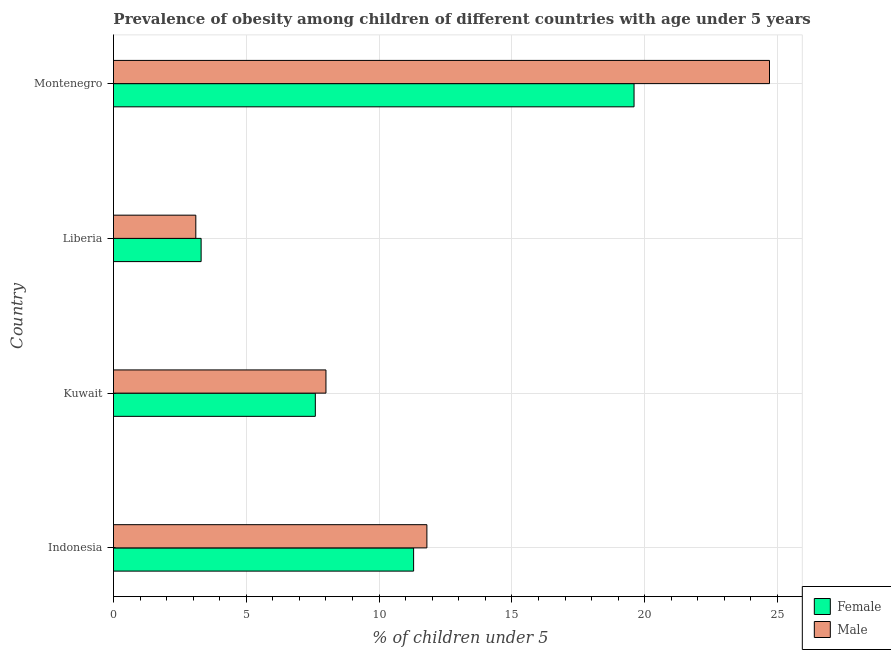How many different coloured bars are there?
Ensure brevity in your answer.  2. Are the number of bars per tick equal to the number of legend labels?
Provide a succinct answer. Yes. Are the number of bars on each tick of the Y-axis equal?
Provide a short and direct response. Yes. How many bars are there on the 3rd tick from the top?
Your response must be concise. 2. What is the label of the 2nd group of bars from the top?
Offer a very short reply. Liberia. In how many cases, is the number of bars for a given country not equal to the number of legend labels?
Your answer should be compact. 0. What is the percentage of obese male children in Liberia?
Your answer should be compact. 3.1. Across all countries, what is the maximum percentage of obese male children?
Ensure brevity in your answer.  24.7. Across all countries, what is the minimum percentage of obese female children?
Provide a succinct answer. 3.3. In which country was the percentage of obese male children maximum?
Your answer should be very brief. Montenegro. In which country was the percentage of obese male children minimum?
Provide a succinct answer. Liberia. What is the total percentage of obese female children in the graph?
Provide a succinct answer. 41.8. What is the difference between the percentage of obese female children in Indonesia and that in Liberia?
Provide a succinct answer. 8. What is the difference between the percentage of obese female children in Indonesia and the percentage of obese male children in Liberia?
Make the answer very short. 8.2. What is the average percentage of obese female children per country?
Make the answer very short. 10.45. In how many countries, is the percentage of obese female children greater than 6 %?
Your answer should be very brief. 3. What is the ratio of the percentage of obese male children in Kuwait to that in Montenegro?
Your answer should be very brief. 0.32. Is the percentage of obese female children in Indonesia less than that in Montenegro?
Provide a succinct answer. Yes. Is the difference between the percentage of obese female children in Indonesia and Liberia greater than the difference between the percentage of obese male children in Indonesia and Liberia?
Give a very brief answer. No. What is the difference between the highest and the second highest percentage of obese male children?
Offer a very short reply. 12.9. What is the difference between the highest and the lowest percentage of obese male children?
Your answer should be compact. 21.6. In how many countries, is the percentage of obese female children greater than the average percentage of obese female children taken over all countries?
Keep it short and to the point. 2. Is the sum of the percentage of obese female children in Indonesia and Liberia greater than the maximum percentage of obese male children across all countries?
Your answer should be compact. No. What does the 2nd bar from the bottom in Kuwait represents?
Offer a terse response. Male. Are all the bars in the graph horizontal?
Offer a terse response. Yes. Are the values on the major ticks of X-axis written in scientific E-notation?
Give a very brief answer. No. Where does the legend appear in the graph?
Offer a terse response. Bottom right. What is the title of the graph?
Make the answer very short. Prevalence of obesity among children of different countries with age under 5 years. Does "Sanitation services" appear as one of the legend labels in the graph?
Give a very brief answer. No. What is the label or title of the X-axis?
Your answer should be very brief.  % of children under 5. What is the  % of children under 5 of Female in Indonesia?
Offer a very short reply. 11.3. What is the  % of children under 5 of Male in Indonesia?
Provide a succinct answer. 11.8. What is the  % of children under 5 in Female in Kuwait?
Your answer should be compact. 7.6. What is the  % of children under 5 in Male in Kuwait?
Your answer should be very brief. 8. What is the  % of children under 5 of Female in Liberia?
Provide a short and direct response. 3.3. What is the  % of children under 5 in Male in Liberia?
Your answer should be compact. 3.1. What is the  % of children under 5 of Female in Montenegro?
Provide a succinct answer. 19.6. What is the  % of children under 5 of Male in Montenegro?
Make the answer very short. 24.7. Across all countries, what is the maximum  % of children under 5 of Female?
Make the answer very short. 19.6. Across all countries, what is the maximum  % of children under 5 in Male?
Your answer should be compact. 24.7. Across all countries, what is the minimum  % of children under 5 in Female?
Offer a very short reply. 3.3. Across all countries, what is the minimum  % of children under 5 of Male?
Provide a succinct answer. 3.1. What is the total  % of children under 5 of Female in the graph?
Your response must be concise. 41.8. What is the total  % of children under 5 of Male in the graph?
Ensure brevity in your answer.  47.6. What is the difference between the  % of children under 5 in Male in Indonesia and that in Kuwait?
Offer a terse response. 3.8. What is the difference between the  % of children under 5 in Male in Indonesia and that in Liberia?
Offer a terse response. 8.7. What is the difference between the  % of children under 5 in Male in Kuwait and that in Liberia?
Your answer should be very brief. 4.9. What is the difference between the  % of children under 5 of Female in Kuwait and that in Montenegro?
Offer a terse response. -12. What is the difference between the  % of children under 5 in Male in Kuwait and that in Montenegro?
Ensure brevity in your answer.  -16.7. What is the difference between the  % of children under 5 of Female in Liberia and that in Montenegro?
Make the answer very short. -16.3. What is the difference between the  % of children under 5 of Male in Liberia and that in Montenegro?
Your response must be concise. -21.6. What is the difference between the  % of children under 5 in Female in Indonesia and the  % of children under 5 in Male in Kuwait?
Your answer should be compact. 3.3. What is the difference between the  % of children under 5 in Female in Kuwait and the  % of children under 5 in Male in Montenegro?
Provide a succinct answer. -17.1. What is the difference between the  % of children under 5 of Female in Liberia and the  % of children under 5 of Male in Montenegro?
Your answer should be compact. -21.4. What is the average  % of children under 5 in Female per country?
Keep it short and to the point. 10.45. What is the difference between the  % of children under 5 of Female and  % of children under 5 of Male in Indonesia?
Your response must be concise. -0.5. What is the difference between the  % of children under 5 in Female and  % of children under 5 in Male in Kuwait?
Provide a short and direct response. -0.4. What is the difference between the  % of children under 5 in Female and  % of children under 5 in Male in Liberia?
Offer a very short reply. 0.2. What is the difference between the  % of children under 5 of Female and  % of children under 5 of Male in Montenegro?
Your response must be concise. -5.1. What is the ratio of the  % of children under 5 of Female in Indonesia to that in Kuwait?
Offer a very short reply. 1.49. What is the ratio of the  % of children under 5 in Male in Indonesia to that in Kuwait?
Your answer should be compact. 1.48. What is the ratio of the  % of children under 5 of Female in Indonesia to that in Liberia?
Offer a terse response. 3.42. What is the ratio of the  % of children under 5 in Male in Indonesia to that in Liberia?
Your answer should be compact. 3.81. What is the ratio of the  % of children under 5 of Female in Indonesia to that in Montenegro?
Keep it short and to the point. 0.58. What is the ratio of the  % of children under 5 in Male in Indonesia to that in Montenegro?
Your response must be concise. 0.48. What is the ratio of the  % of children under 5 of Female in Kuwait to that in Liberia?
Your answer should be very brief. 2.3. What is the ratio of the  % of children under 5 of Male in Kuwait to that in Liberia?
Ensure brevity in your answer.  2.58. What is the ratio of the  % of children under 5 of Female in Kuwait to that in Montenegro?
Your answer should be very brief. 0.39. What is the ratio of the  % of children under 5 of Male in Kuwait to that in Montenegro?
Keep it short and to the point. 0.32. What is the ratio of the  % of children under 5 in Female in Liberia to that in Montenegro?
Your response must be concise. 0.17. What is the ratio of the  % of children under 5 in Male in Liberia to that in Montenegro?
Offer a terse response. 0.13. What is the difference between the highest and the second highest  % of children under 5 of Female?
Provide a short and direct response. 8.3. What is the difference between the highest and the second highest  % of children under 5 of Male?
Keep it short and to the point. 12.9. What is the difference between the highest and the lowest  % of children under 5 in Female?
Offer a terse response. 16.3. What is the difference between the highest and the lowest  % of children under 5 in Male?
Provide a succinct answer. 21.6. 